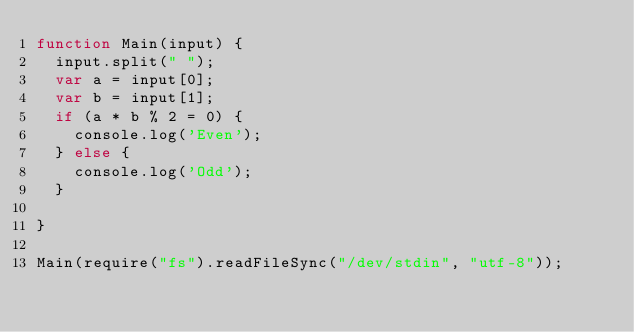Convert code to text. <code><loc_0><loc_0><loc_500><loc_500><_JavaScript_>function Main(input) {
  input.split(" ");
  var a = input[0];
  var b = input[1];
  if (a * b % 2 = 0) {
    console.log('Even');
  } else {
    console.log('Odd');
  }
  
}

Main(require("fs").readFileSync("/dev/stdin", "utf-8"));</code> 